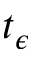<formula> <loc_0><loc_0><loc_500><loc_500>t _ { \epsilon }</formula> 